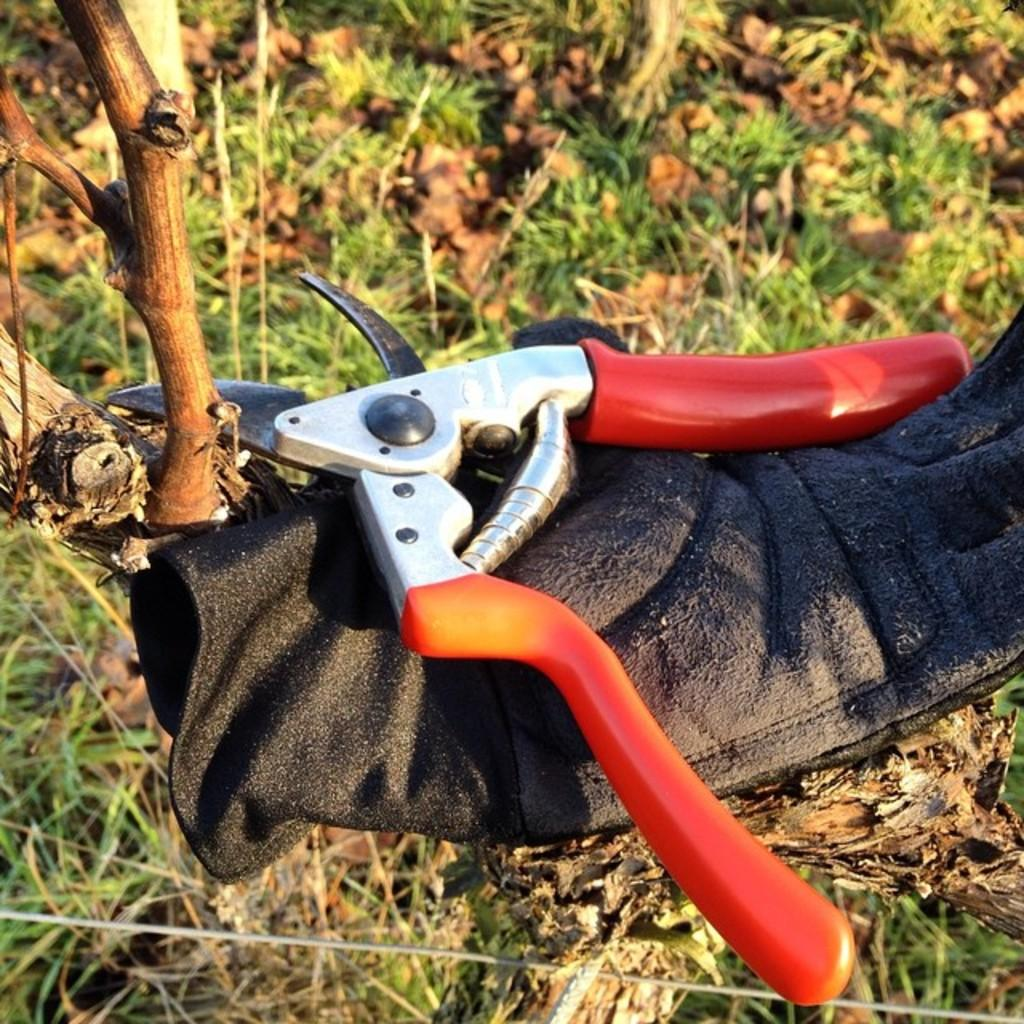What is the main object in the image? There is a cutting player in the image. What is the cutting player placed on? The cutting player is placed on a black cloth. What type of surface can be seen at the bottom of the image? There is grass visible at the bottom of the image. What story is the person reading in the image? There is no person or reading material present in the image; it only features a cutting player placed on a black cloth with grass visible at the bottom. 